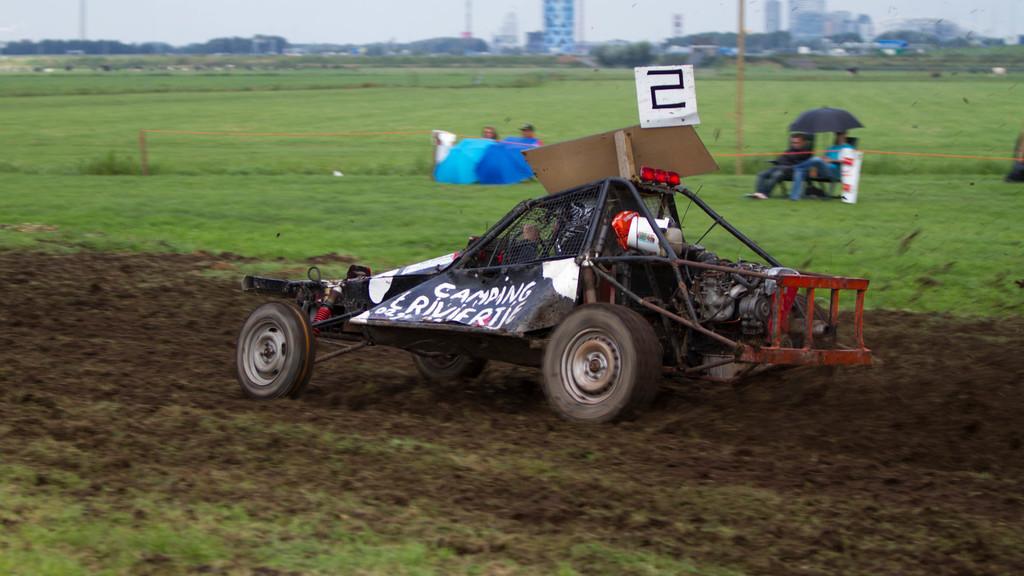How would you summarize this image in a sentence or two? In the picture we can see a sports car on the muddy surface and behind it, we can see a grass surface with two people are sitting under the umbrella and beside it two people are sitting and on them, we can see a blue colored cloth and in the background we can see trees, buildings, poles and sky. 